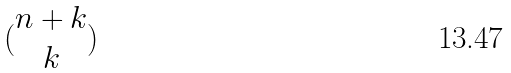<formula> <loc_0><loc_0><loc_500><loc_500>( \begin{matrix} n + k \\ k \end{matrix} )</formula> 